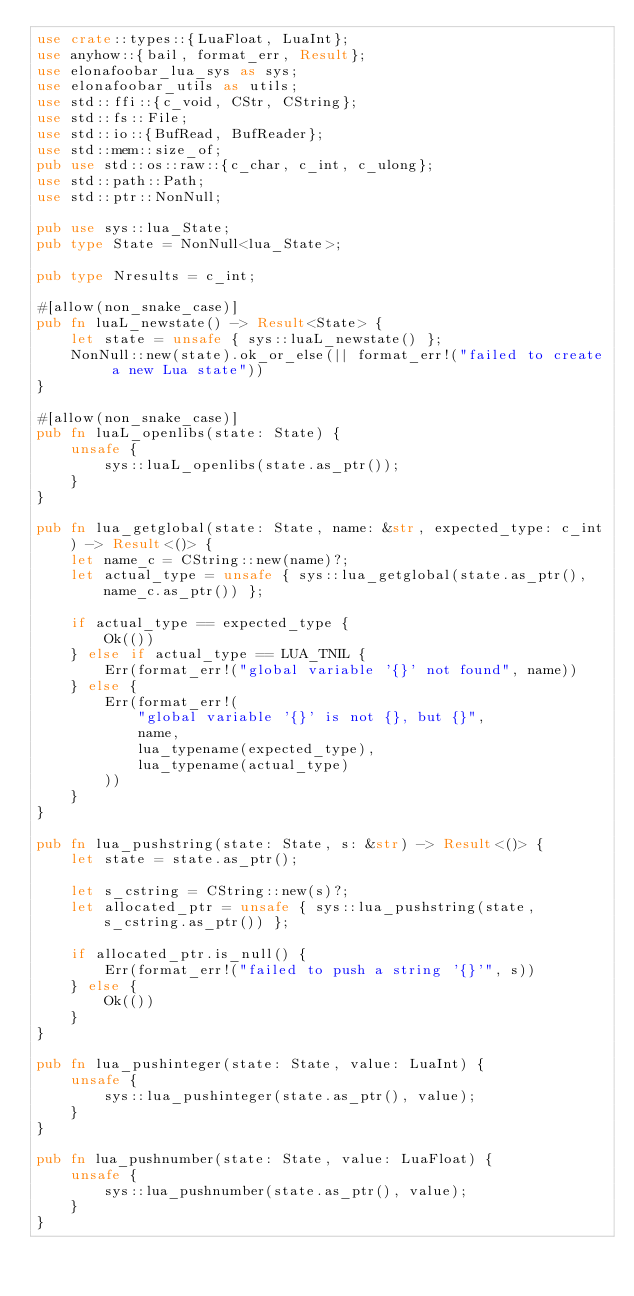Convert code to text. <code><loc_0><loc_0><loc_500><loc_500><_Rust_>use crate::types::{LuaFloat, LuaInt};
use anyhow::{bail, format_err, Result};
use elonafoobar_lua_sys as sys;
use elonafoobar_utils as utils;
use std::ffi::{c_void, CStr, CString};
use std::fs::File;
use std::io::{BufRead, BufReader};
use std::mem::size_of;
pub use std::os::raw::{c_char, c_int, c_ulong};
use std::path::Path;
use std::ptr::NonNull;

pub use sys::lua_State;
pub type State = NonNull<lua_State>;

pub type Nresults = c_int;

#[allow(non_snake_case)]
pub fn luaL_newstate() -> Result<State> {
    let state = unsafe { sys::luaL_newstate() };
    NonNull::new(state).ok_or_else(|| format_err!("failed to create a new Lua state"))
}

#[allow(non_snake_case)]
pub fn luaL_openlibs(state: State) {
    unsafe {
        sys::luaL_openlibs(state.as_ptr());
    }
}

pub fn lua_getglobal(state: State, name: &str, expected_type: c_int) -> Result<()> {
    let name_c = CString::new(name)?;
    let actual_type = unsafe { sys::lua_getglobal(state.as_ptr(), name_c.as_ptr()) };

    if actual_type == expected_type {
        Ok(())
    } else if actual_type == LUA_TNIL {
        Err(format_err!("global variable '{}' not found", name))
    } else {
        Err(format_err!(
            "global variable '{}' is not {}, but {}",
            name,
            lua_typename(expected_type),
            lua_typename(actual_type)
        ))
    }
}

pub fn lua_pushstring(state: State, s: &str) -> Result<()> {
    let state = state.as_ptr();

    let s_cstring = CString::new(s)?;
    let allocated_ptr = unsafe { sys::lua_pushstring(state, s_cstring.as_ptr()) };

    if allocated_ptr.is_null() {
        Err(format_err!("failed to push a string '{}'", s))
    } else {
        Ok(())
    }
}

pub fn lua_pushinteger(state: State, value: LuaInt) {
    unsafe {
        sys::lua_pushinteger(state.as_ptr(), value);
    }
}

pub fn lua_pushnumber(state: State, value: LuaFloat) {
    unsafe {
        sys::lua_pushnumber(state.as_ptr(), value);
    }
}
</code> 